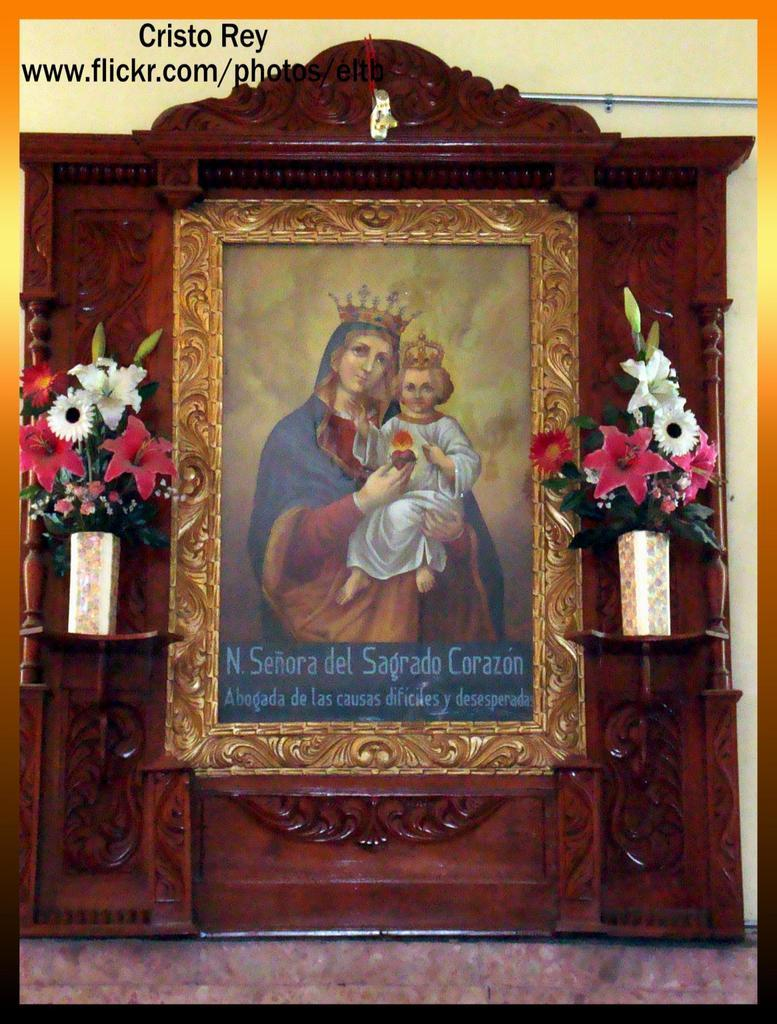<image>
Relay a brief, clear account of the picture shown. a Senora del Sagrado painting with flowers on the side of it 